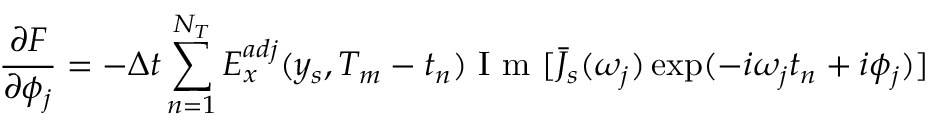<formula> <loc_0><loc_0><loc_500><loc_500>\frac { \partial F } { \partial \phi _ { j } } = - \Delta t \sum _ { n = 1 } ^ { N _ { T } } E _ { x } ^ { a d j } ( y _ { s } , T _ { m } - t _ { n } ) I m [ \bar { J } _ { s } ( \omega _ { j } ) \exp ( - i \omega _ { j } t _ { n } + i \phi _ { j } ) ]</formula> 